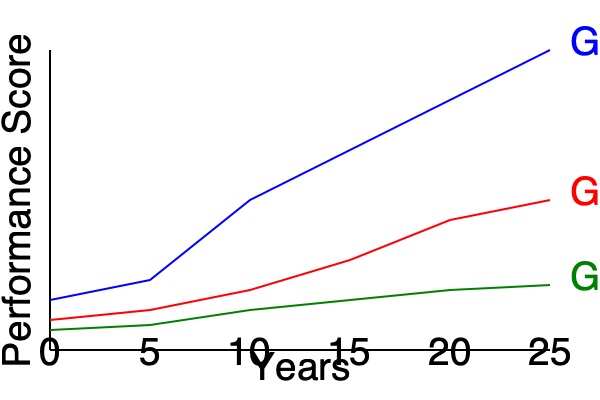In this longitudinal study spanning 25 years, which group shows the most significant improvement in performance scores, and what is the approximate difference between its initial and final scores? To answer this question, we need to analyze the trends for each group and calculate the improvement in performance scores:

1. Identify the three groups:
   - Blue line: Group A
   - Red line: Group B
   - Green line: Group C

2. Analyze the trends:
   - Group A (Blue): Shows the steepest upward trend
   - Group B (Red): Shows a moderate upward trend
   - Group C (Green): Shows a slight upward trend

3. Calculate the approximate improvement for Group A (the most significant):
   - Initial score (Year 0): ~50
   - Final score (Year 25): ~300
   - Improvement: 300 - 50 = 250

4. Compare with other groups:
   - Group B: Improvement from ~30 to ~150 (120 points)
   - Group C: Improvement from ~20 to ~65 (45 points)

5. Conclusion:
   Group A shows the most significant improvement with an approximate difference of 250 points between its initial and final scores.
Answer: Group A, 250 points 